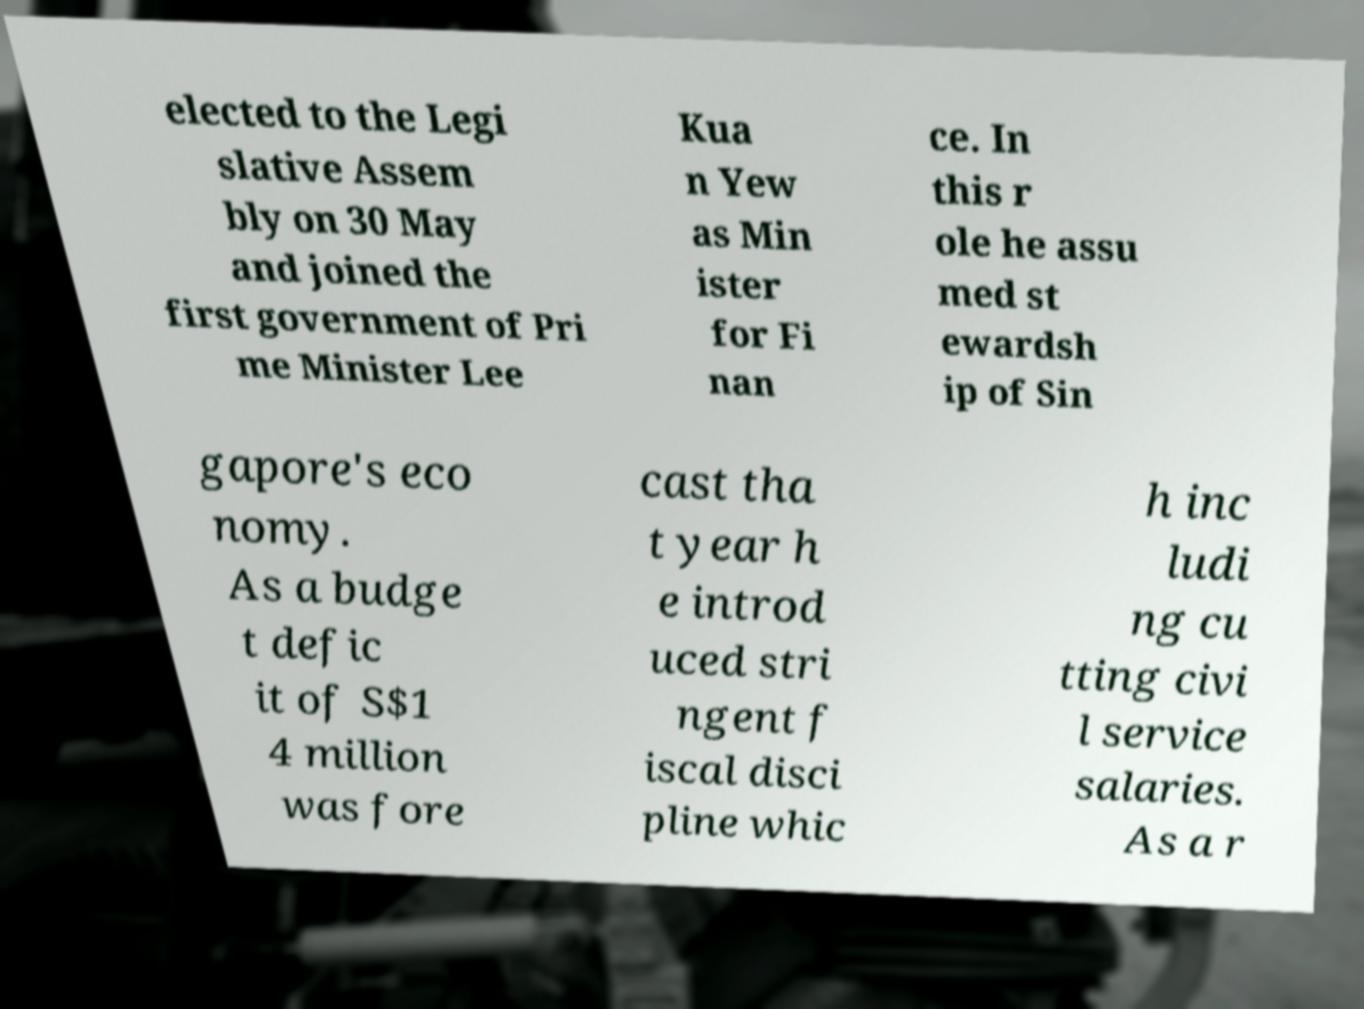Can you accurately transcribe the text from the provided image for me? elected to the Legi slative Assem bly on 30 May and joined the first government of Pri me Minister Lee Kua n Yew as Min ister for Fi nan ce. In this r ole he assu med st ewardsh ip of Sin gapore's eco nomy. As a budge t defic it of S$1 4 million was fore cast tha t year h e introd uced stri ngent f iscal disci pline whic h inc ludi ng cu tting civi l service salaries. As a r 